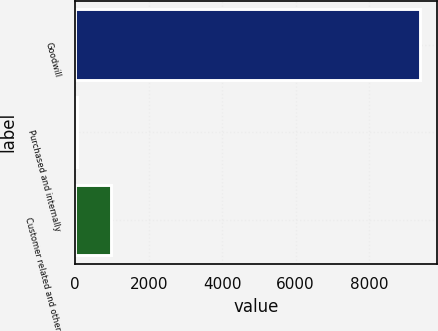Convert chart. <chart><loc_0><loc_0><loc_500><loc_500><bar_chart><fcel>Goodwill<fcel>Purchased and internally<fcel>Customer related and other<nl><fcel>9384.3<fcel>54.2<fcel>987.21<nl></chart> 